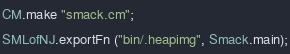<code> <loc_0><loc_0><loc_500><loc_500><_SML_>CM.make "smack.cm";
SMLofNJ.exportFn ("bin/.heapimg", Smack.main);
</code> 